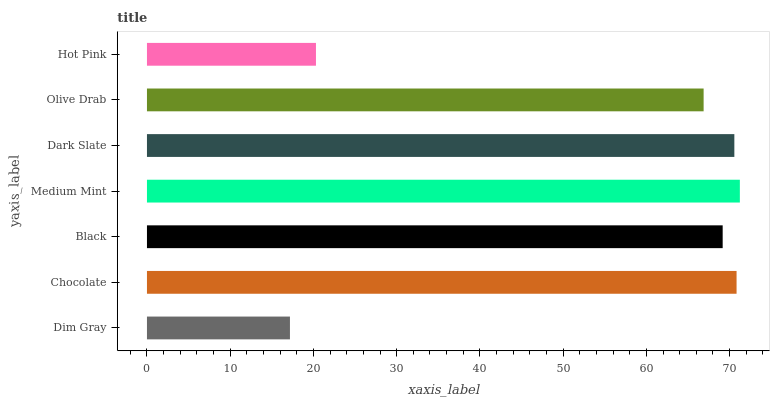Is Dim Gray the minimum?
Answer yes or no. Yes. Is Medium Mint the maximum?
Answer yes or no. Yes. Is Chocolate the minimum?
Answer yes or no. No. Is Chocolate the maximum?
Answer yes or no. No. Is Chocolate greater than Dim Gray?
Answer yes or no. Yes. Is Dim Gray less than Chocolate?
Answer yes or no. Yes. Is Dim Gray greater than Chocolate?
Answer yes or no. No. Is Chocolate less than Dim Gray?
Answer yes or no. No. Is Black the high median?
Answer yes or no. Yes. Is Black the low median?
Answer yes or no. Yes. Is Dim Gray the high median?
Answer yes or no. No. Is Dark Slate the low median?
Answer yes or no. No. 